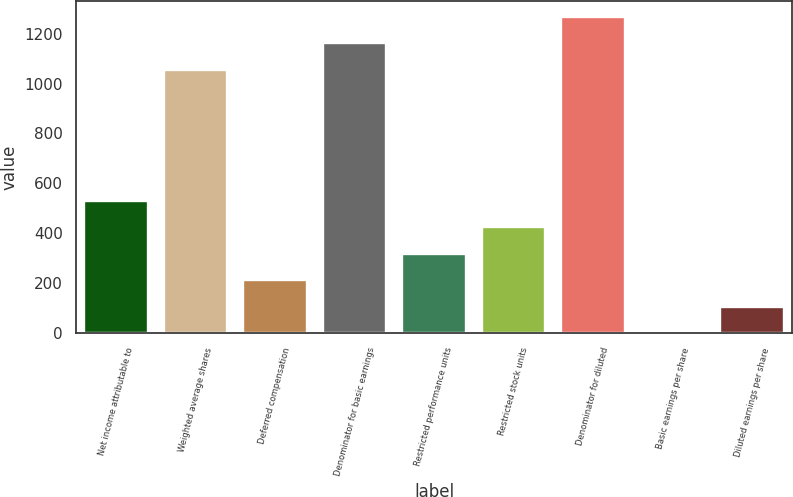Convert chart to OTSL. <chart><loc_0><loc_0><loc_500><loc_500><bar_chart><fcel>Net income attributable to<fcel>Weighted average shares<fcel>Deferred compensation<fcel>Denominator for basic earnings<fcel>Restricted performance units<fcel>Restricted stock units<fcel>Denominator for diluted<fcel>Basic earnings per share<fcel>Diluted earnings per share<nl><fcel>531.66<fcel>1055<fcel>212.88<fcel>1161.26<fcel>319.14<fcel>425.4<fcel>1267.52<fcel>0.36<fcel>106.62<nl></chart> 